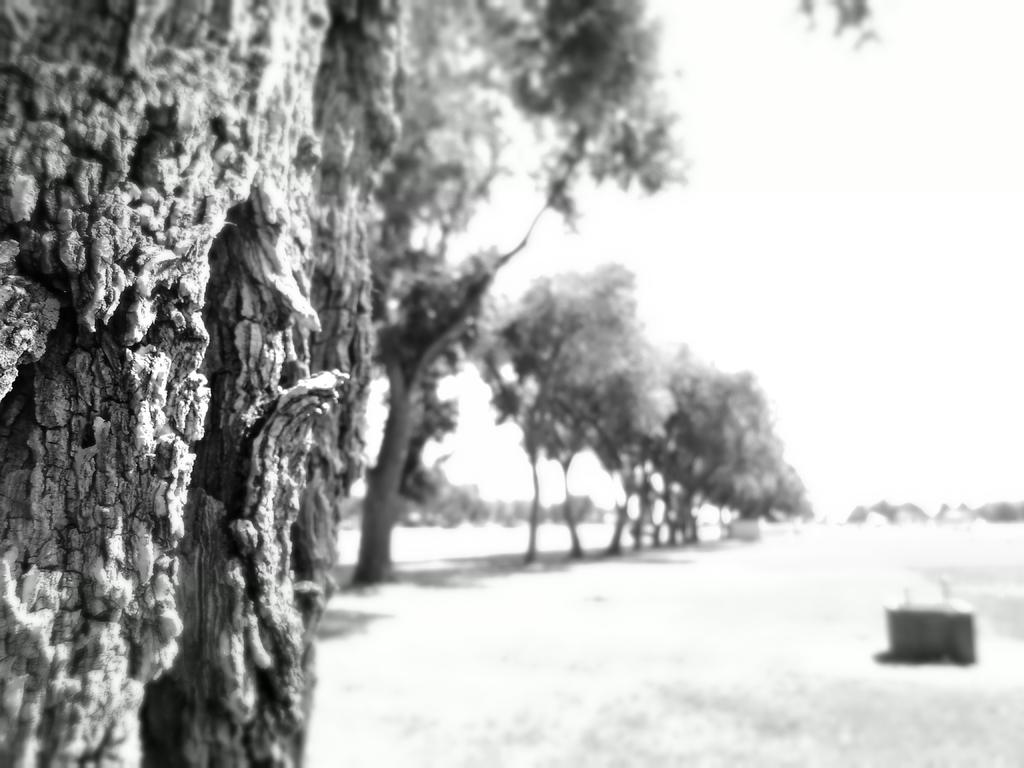What is the color scheme of the image? The image is black and white. What type of natural elements can be seen in the image? There are trees in the image. What is located on the ground in the image? There is an object on the ground in the image. What can be seen in the background of the image? The sky is visible in the background of the image. What type of wax is being used to play a border in the image? There is no wax or playable border present in the image. 